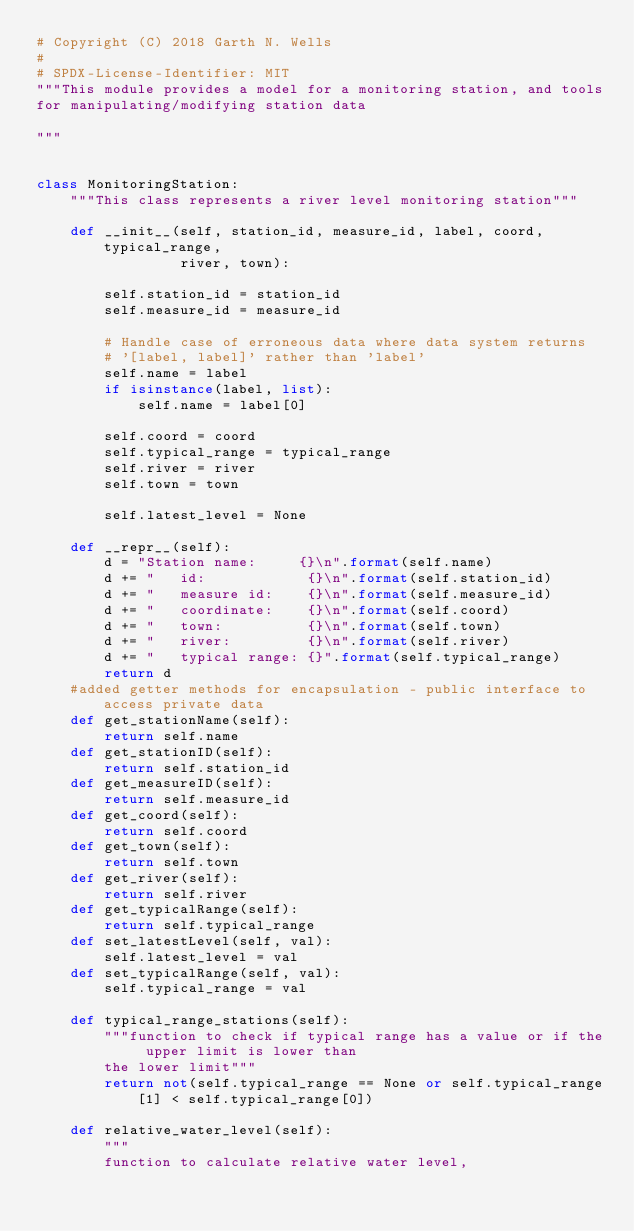<code> <loc_0><loc_0><loc_500><loc_500><_Python_># Copyright (C) 2018 Garth N. Wells
#
# SPDX-License-Identifier: MIT
"""This module provides a model for a monitoring station, and tools
for manipulating/modifying station data

"""


class MonitoringStation:
    """This class represents a river level monitoring station"""

    def __init__(self, station_id, measure_id, label, coord, typical_range,
                 river, town):

        self.station_id = station_id
        self.measure_id = measure_id

        # Handle case of erroneous data where data system returns
        # '[label, label]' rather than 'label'
        self.name = label
        if isinstance(label, list):
            self.name = label[0]

        self.coord = coord
        self.typical_range = typical_range
        self.river = river
        self.town = town

        self.latest_level = None

    def __repr__(self):
        d = "Station name:     {}\n".format(self.name)
        d += "   id:            {}\n".format(self.station_id)
        d += "   measure id:    {}\n".format(self.measure_id)
        d += "   coordinate:    {}\n".format(self.coord)
        d += "   town:          {}\n".format(self.town)
        d += "   river:         {}\n".format(self.river)
        d += "   typical range: {}".format(self.typical_range)
        return d
    #added getter methods for encapsulation - public interface to access private data 
    def get_stationName(self):
        return self.name
    def get_stationID(self):
        return self.station_id
    def get_measureID(self):
        return self.measure_id
    def get_coord(self):
        return self.coord
    def get_town(self):
        return self.town
    def get_river(self):
        return self.river
    def get_typicalRange(self):
        return self.typical_range
    def set_latestLevel(self, val):
        self.latest_level = val
    def set_typicalRange(self, val):
        self.typical_range = val
        
    def typical_range_stations(self):
        """function to check if typical range has a value or if the upper limit is lower than 
        the lower limit"""
        return not(self.typical_range == None or self.typical_range[1] < self.typical_range[0])

    def relative_water_level(self):
        """
        function to calculate relative water level,</code> 